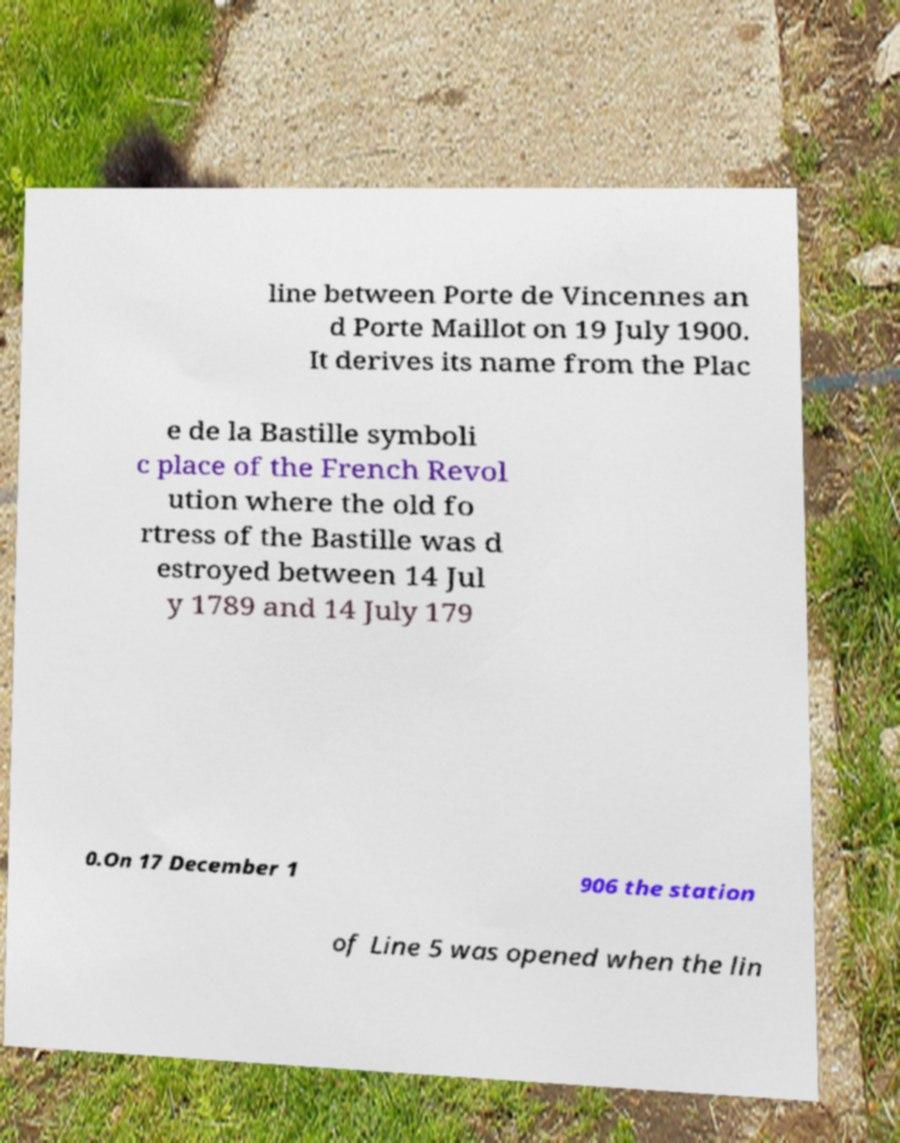Could you assist in decoding the text presented in this image and type it out clearly? line between Porte de Vincennes an d Porte Maillot on 19 July 1900. It derives its name from the Plac e de la Bastille symboli c place of the French Revol ution where the old fo rtress of the Bastille was d estroyed between 14 Jul y 1789 and 14 July 179 0.On 17 December 1 906 the station of Line 5 was opened when the lin 